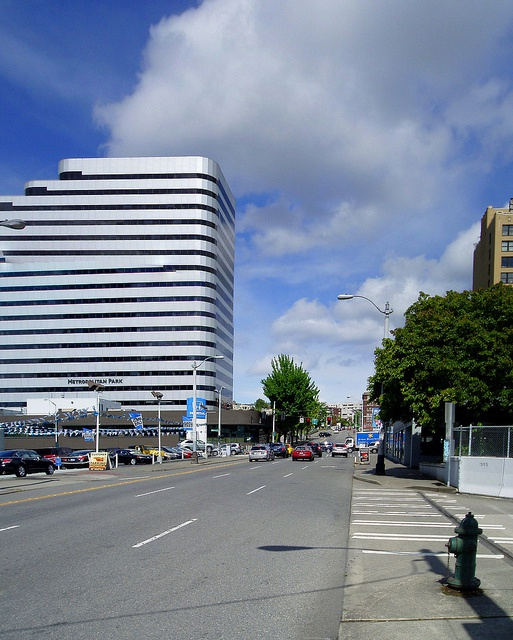Describe the objects in this image and their specific colors. I can see fire hydrant in blue, black, gray, teal, and darkgreen tones, car in blue, black, navy, and gray tones, car in blue, darkgray, gray, black, and lightgray tones, car in blue, black, gray, navy, and darkgray tones, and car in blue, darkgray, gray, lightgray, and black tones in this image. 